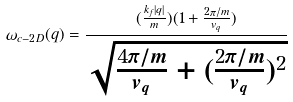<formula> <loc_0><loc_0><loc_500><loc_500>\omega _ { c - 2 D } ( { q } ) = \frac { ( \frac { k _ { f } | { q } | } { m } ) ( 1 + \frac { 2 \pi / m } { v _ { q } } ) } { \sqrt { \frac { 4 \pi / m } { v _ { q } } + ( \frac { 2 \pi / m } { v _ { q } } ) ^ { 2 } } }</formula> 